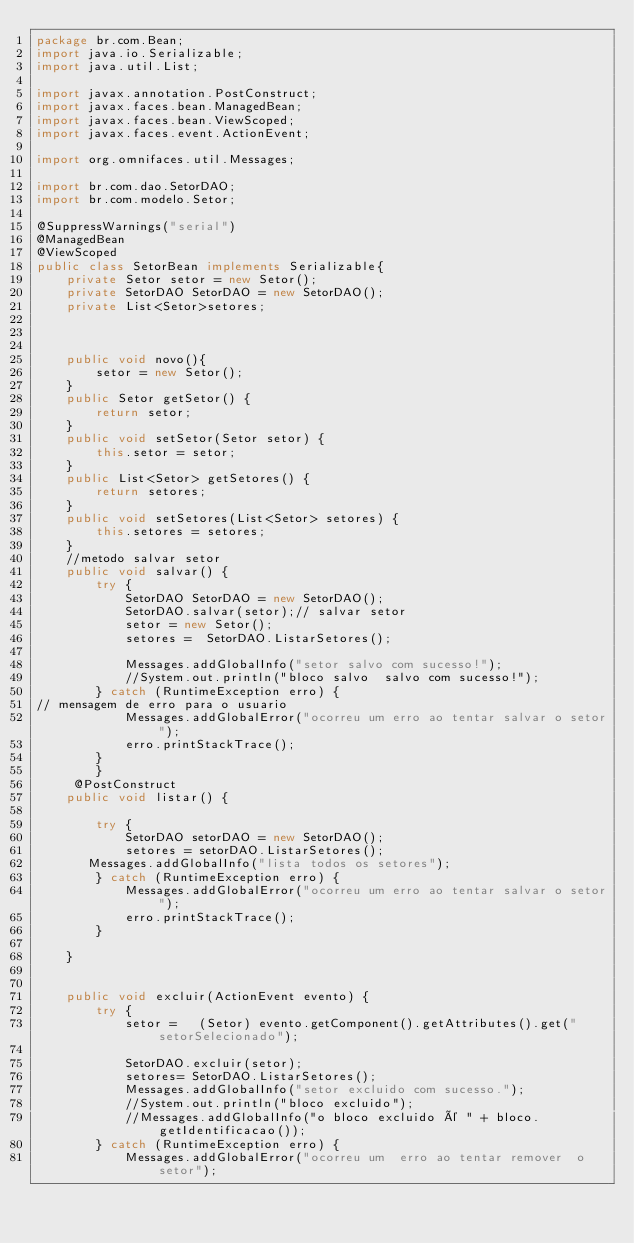<code> <loc_0><loc_0><loc_500><loc_500><_Java_>package br.com.Bean;
import java.io.Serializable;
import java.util.List;

import javax.annotation.PostConstruct;
import javax.faces.bean.ManagedBean;
import javax.faces.bean.ViewScoped;
import javax.faces.event.ActionEvent;

import org.omnifaces.util.Messages;

import br.com.dao.SetorDAO;
import br.com.modelo.Setor;

@SuppressWarnings("serial")
@ManagedBean 
@ViewScoped
public class SetorBean implements Serializable{
	private Setor setor = new Setor();
	private SetorDAO SetorDAO = new SetorDAO();
	private List<Setor>setores;
	 

	
	public void novo(){
		setor = new Setor();
	}
	public Setor getSetor() {
		return setor;
	}
	public void setSetor(Setor setor) {
		this.setor = setor;
	}
	public List<Setor> getSetores() {
		return setores;
	}
	public void setSetores(List<Setor> setores) {
		this.setores = setores;
	}
	//metodo salvar setor
	public void salvar() {
		try {
			SetorDAO SetorDAO = new SetorDAO();
            SetorDAO.salvar(setor);// salvar setor
			setor = new Setor();
		    setores =  SetorDAO.ListarSetores();
	 
			Messages.addGlobalInfo("setor salvo com sucesso!");
			//System.out.println("bloco salvo  salvo com sucesso!");
		} catch (RuntimeException erro) {
// mensagem de erro para o usuario 
			Messages.addGlobalError("ocorreu um erro ao tentar salvar o setor");
			erro.printStackTrace();	 
		}
		}
	 @PostConstruct
	public void listar() {

		try {
			SetorDAO setorDAO = new SetorDAO();
			setores = setorDAO.ListarSetores();
       Messages.addGlobalInfo("lista todos os setores");
		} catch (RuntimeException erro) {
			Messages.addGlobalError("ocorreu um erro ao tentar salvar o setor");
			erro.printStackTrace();
		}

	}
	
	 
	public void excluir(ActionEvent evento) {
		try {
			setor =   (Setor) evento.getComponent().getAttributes().get("setorSelecionado");
			
			SetorDAO.excluir(setor);
			setores= SetorDAO.ListarSetores();
			Messages.addGlobalInfo("setor excluido com sucesso.");
			//System.out.println("bloco excluido");
			//Messages.addGlobalInfo("o bloco excluido é " + bloco.getIdentificacao());
		} catch (RuntimeException erro) {
			Messages.addGlobalError("ocorreu um  erro ao tentar remover  o setor");</code> 